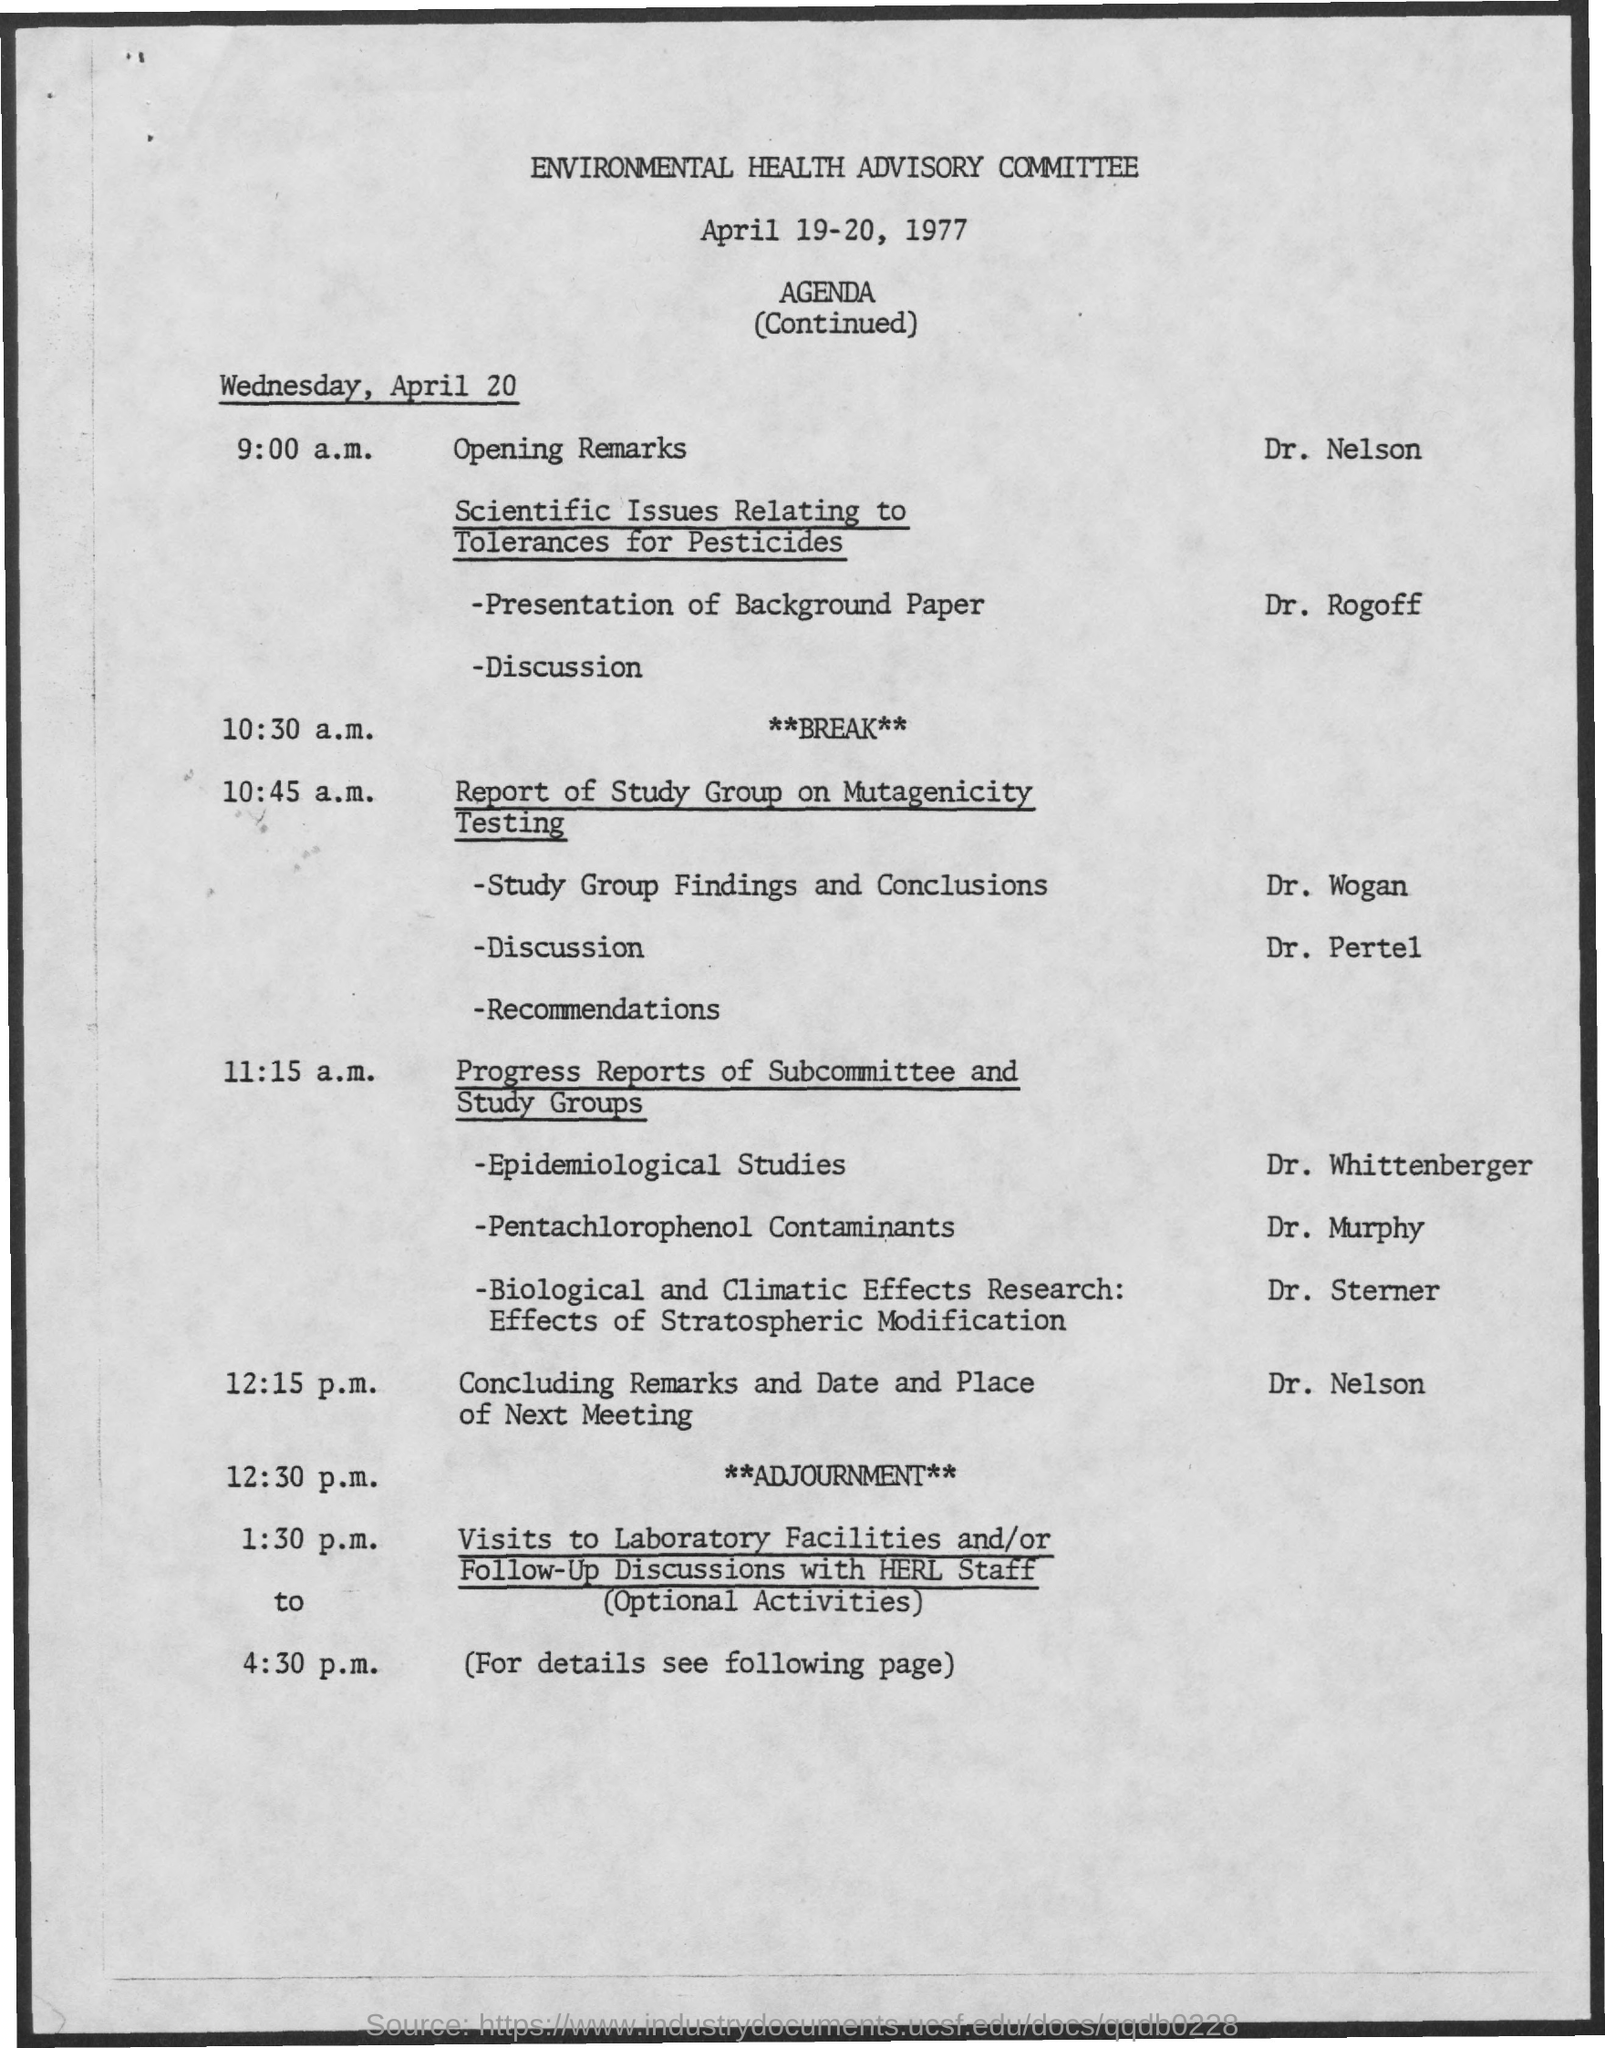When is the Environmental Health Advisory Committee held?
Offer a terse response. April 19-20, 1977. Who is presenting Opening remarks?
Offer a terse response. Dr. Nelson. Who is doing the presentation on Background Paper?
Offer a terse response. DR. ROGOFF. When is the Break?
Give a very brief answer. 10:30 a.m. Who is doing the presentation on Epidemiology Studies?
Provide a succinct answer. Dr. Whittenberger. Who is doing the presentation on Pentachlorophenol Contaminants?
Ensure brevity in your answer.  Dr. Murphy. When is the Adjournment?
Give a very brief answer. 12:30 P.M. When are the visits to Laboratory Facilities?
Your answer should be compact. 1:30 p.m. to 4:30 p.m. 